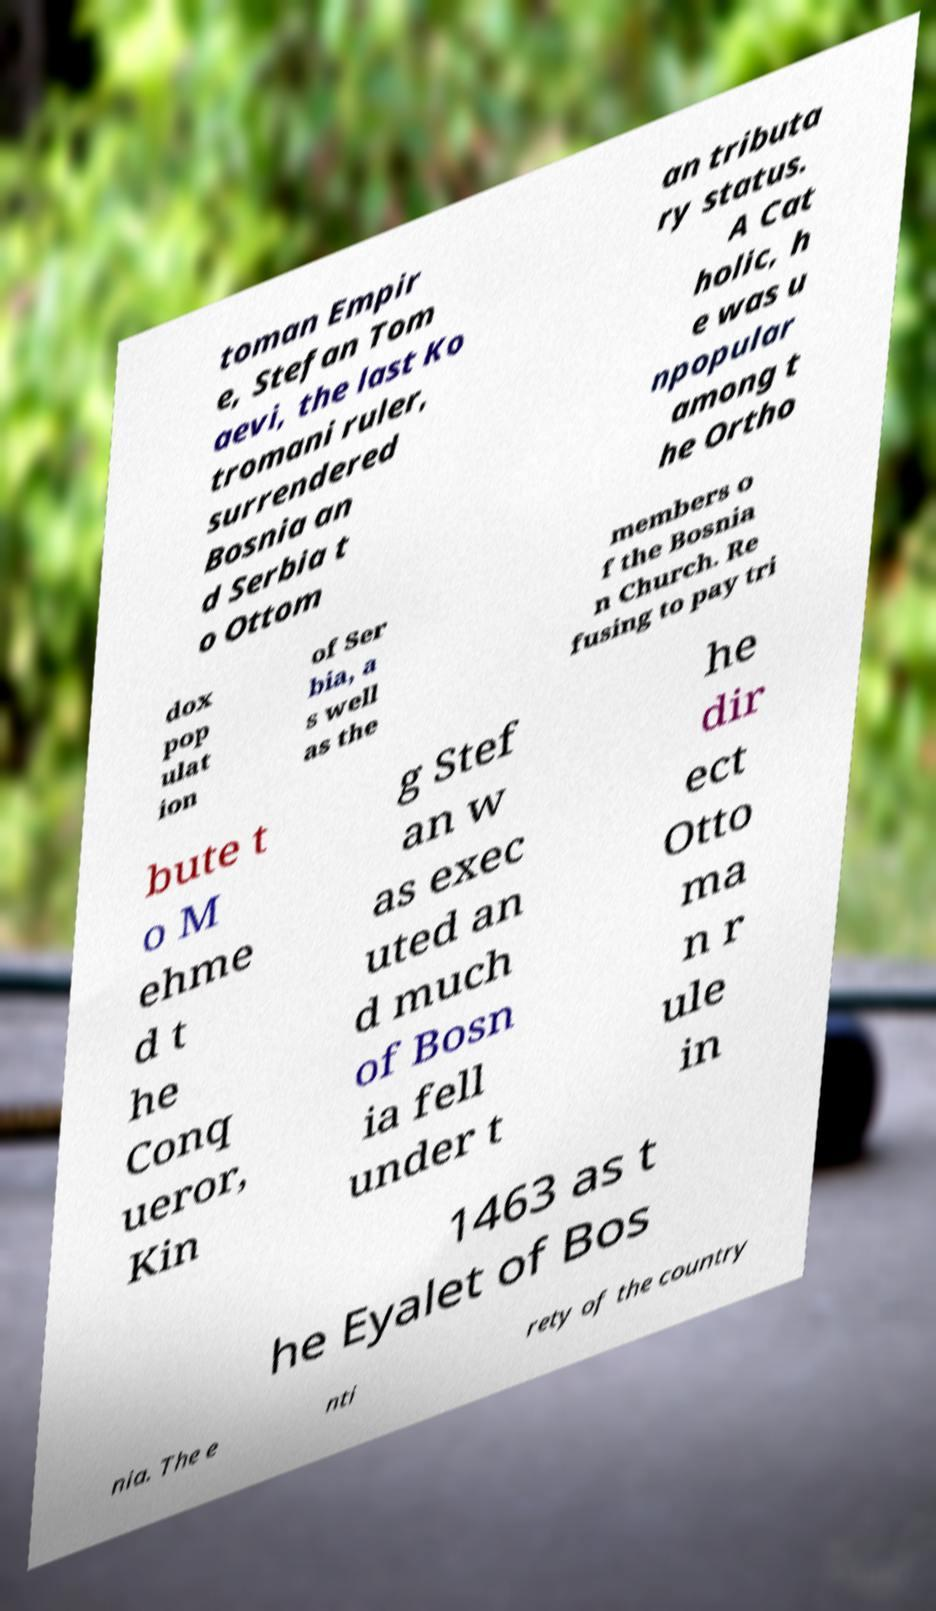Can you accurately transcribe the text from the provided image for me? toman Empir e, Stefan Tom aevi, the last Ko tromani ruler, surrendered Bosnia an d Serbia t o Ottom an tributa ry status. A Cat holic, h e was u npopular among t he Ortho dox pop ulat ion of Ser bia, a s well as the members o f the Bosnia n Church. Re fusing to pay tri bute t o M ehme d t he Conq ueror, Kin g Stef an w as exec uted an d much of Bosn ia fell under t he dir ect Otto ma n r ule in 1463 as t he Eyalet of Bos nia. The e nti rety of the country 